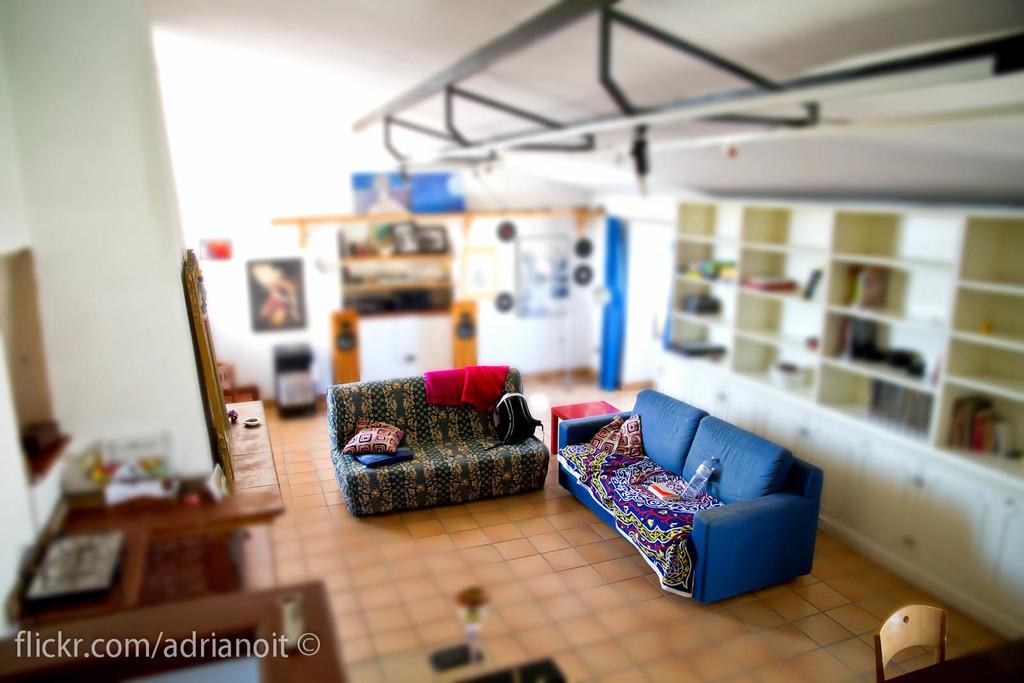<image>
Offer a succinct explanation of the picture presented. A view of a living room and its couches with a flickr link in the corner. 